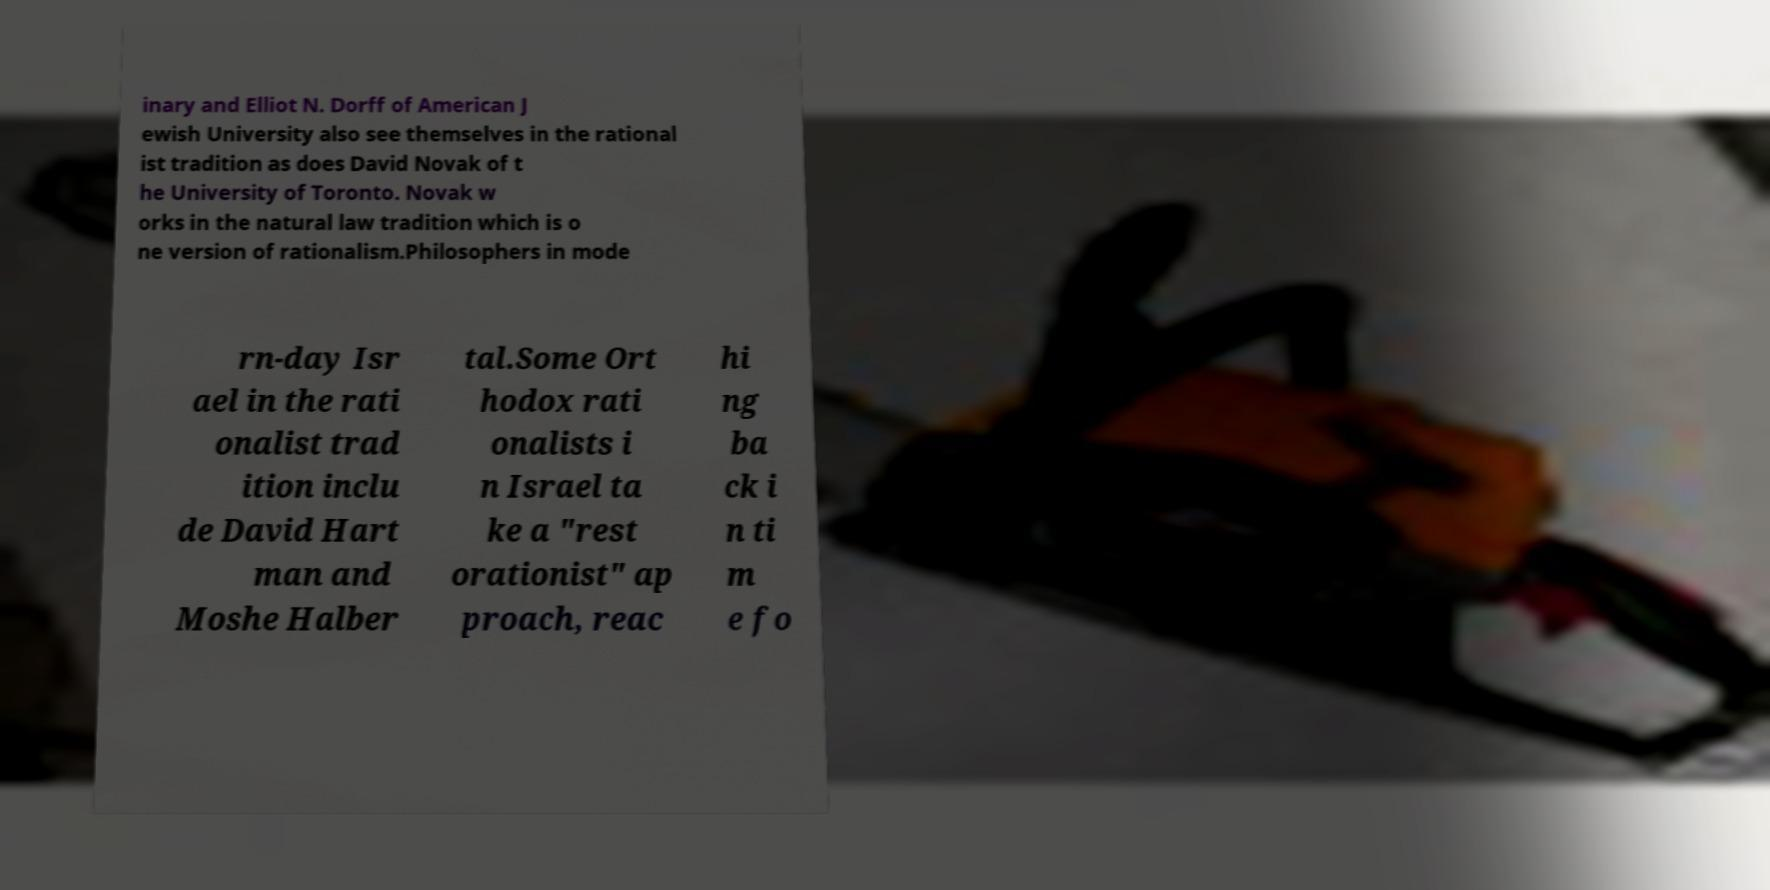For documentation purposes, I need the text within this image transcribed. Could you provide that? inary and Elliot N. Dorff of American J ewish University also see themselves in the rational ist tradition as does David Novak of t he University of Toronto. Novak w orks in the natural law tradition which is o ne version of rationalism.Philosophers in mode rn-day Isr ael in the rati onalist trad ition inclu de David Hart man and Moshe Halber tal.Some Ort hodox rati onalists i n Israel ta ke a "rest orationist" ap proach, reac hi ng ba ck i n ti m e fo 